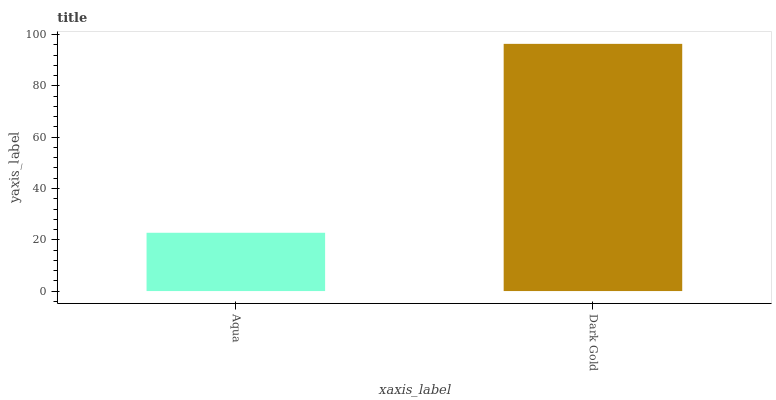Is Dark Gold the minimum?
Answer yes or no. No. Is Dark Gold greater than Aqua?
Answer yes or no. Yes. Is Aqua less than Dark Gold?
Answer yes or no. Yes. Is Aqua greater than Dark Gold?
Answer yes or no. No. Is Dark Gold less than Aqua?
Answer yes or no. No. Is Dark Gold the high median?
Answer yes or no. Yes. Is Aqua the low median?
Answer yes or no. Yes. Is Aqua the high median?
Answer yes or no. No. Is Dark Gold the low median?
Answer yes or no. No. 